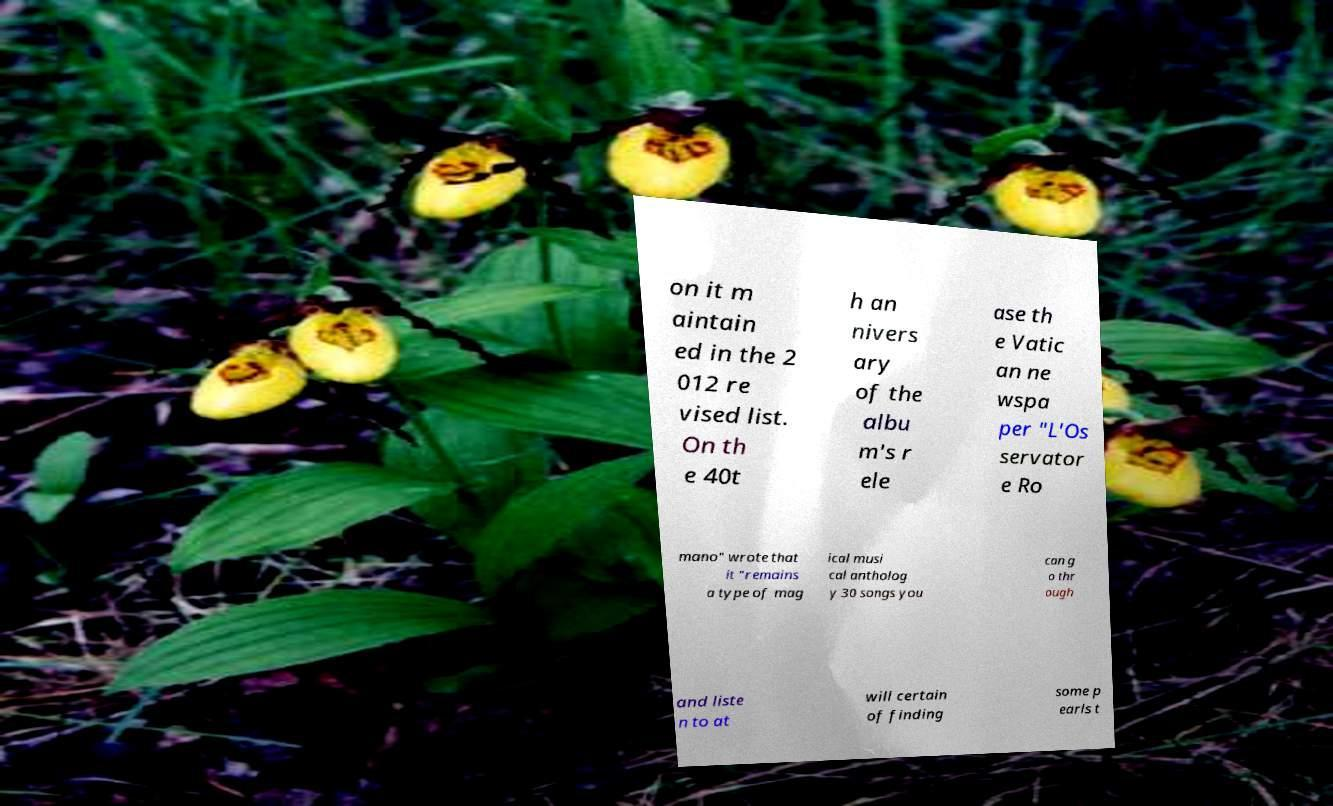Can you read and provide the text displayed in the image?This photo seems to have some interesting text. Can you extract and type it out for me? on it m aintain ed in the 2 012 re vised list. On th e 40t h an nivers ary of the albu m's r ele ase th e Vatic an ne wspa per "L'Os servator e Ro mano" wrote that it "remains a type of mag ical musi cal antholog y 30 songs you can g o thr ough and liste n to at will certain of finding some p earls t 